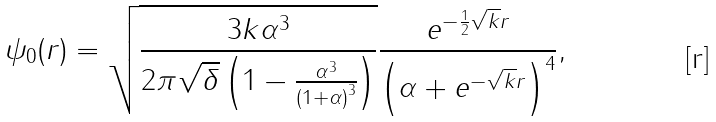Convert formula to latex. <formula><loc_0><loc_0><loc_500><loc_500>\psi _ { 0 } ( r ) = \sqrt { \frac { 3 k \alpha ^ { 3 } } { { 2 \pi \sqrt { \delta } \left ( { 1 - \frac { \alpha ^ { 3 } } { { \left ( { 1 + \alpha } \right ) ^ { 3 } } } } \right ) } } } \frac { { e ^ { - \frac { 1 } { 2 } \sqrt { k } r } } } { { \left ( { \alpha + e ^ { - \sqrt { k } r } } \right ) ^ { 4 } } } ,</formula> 